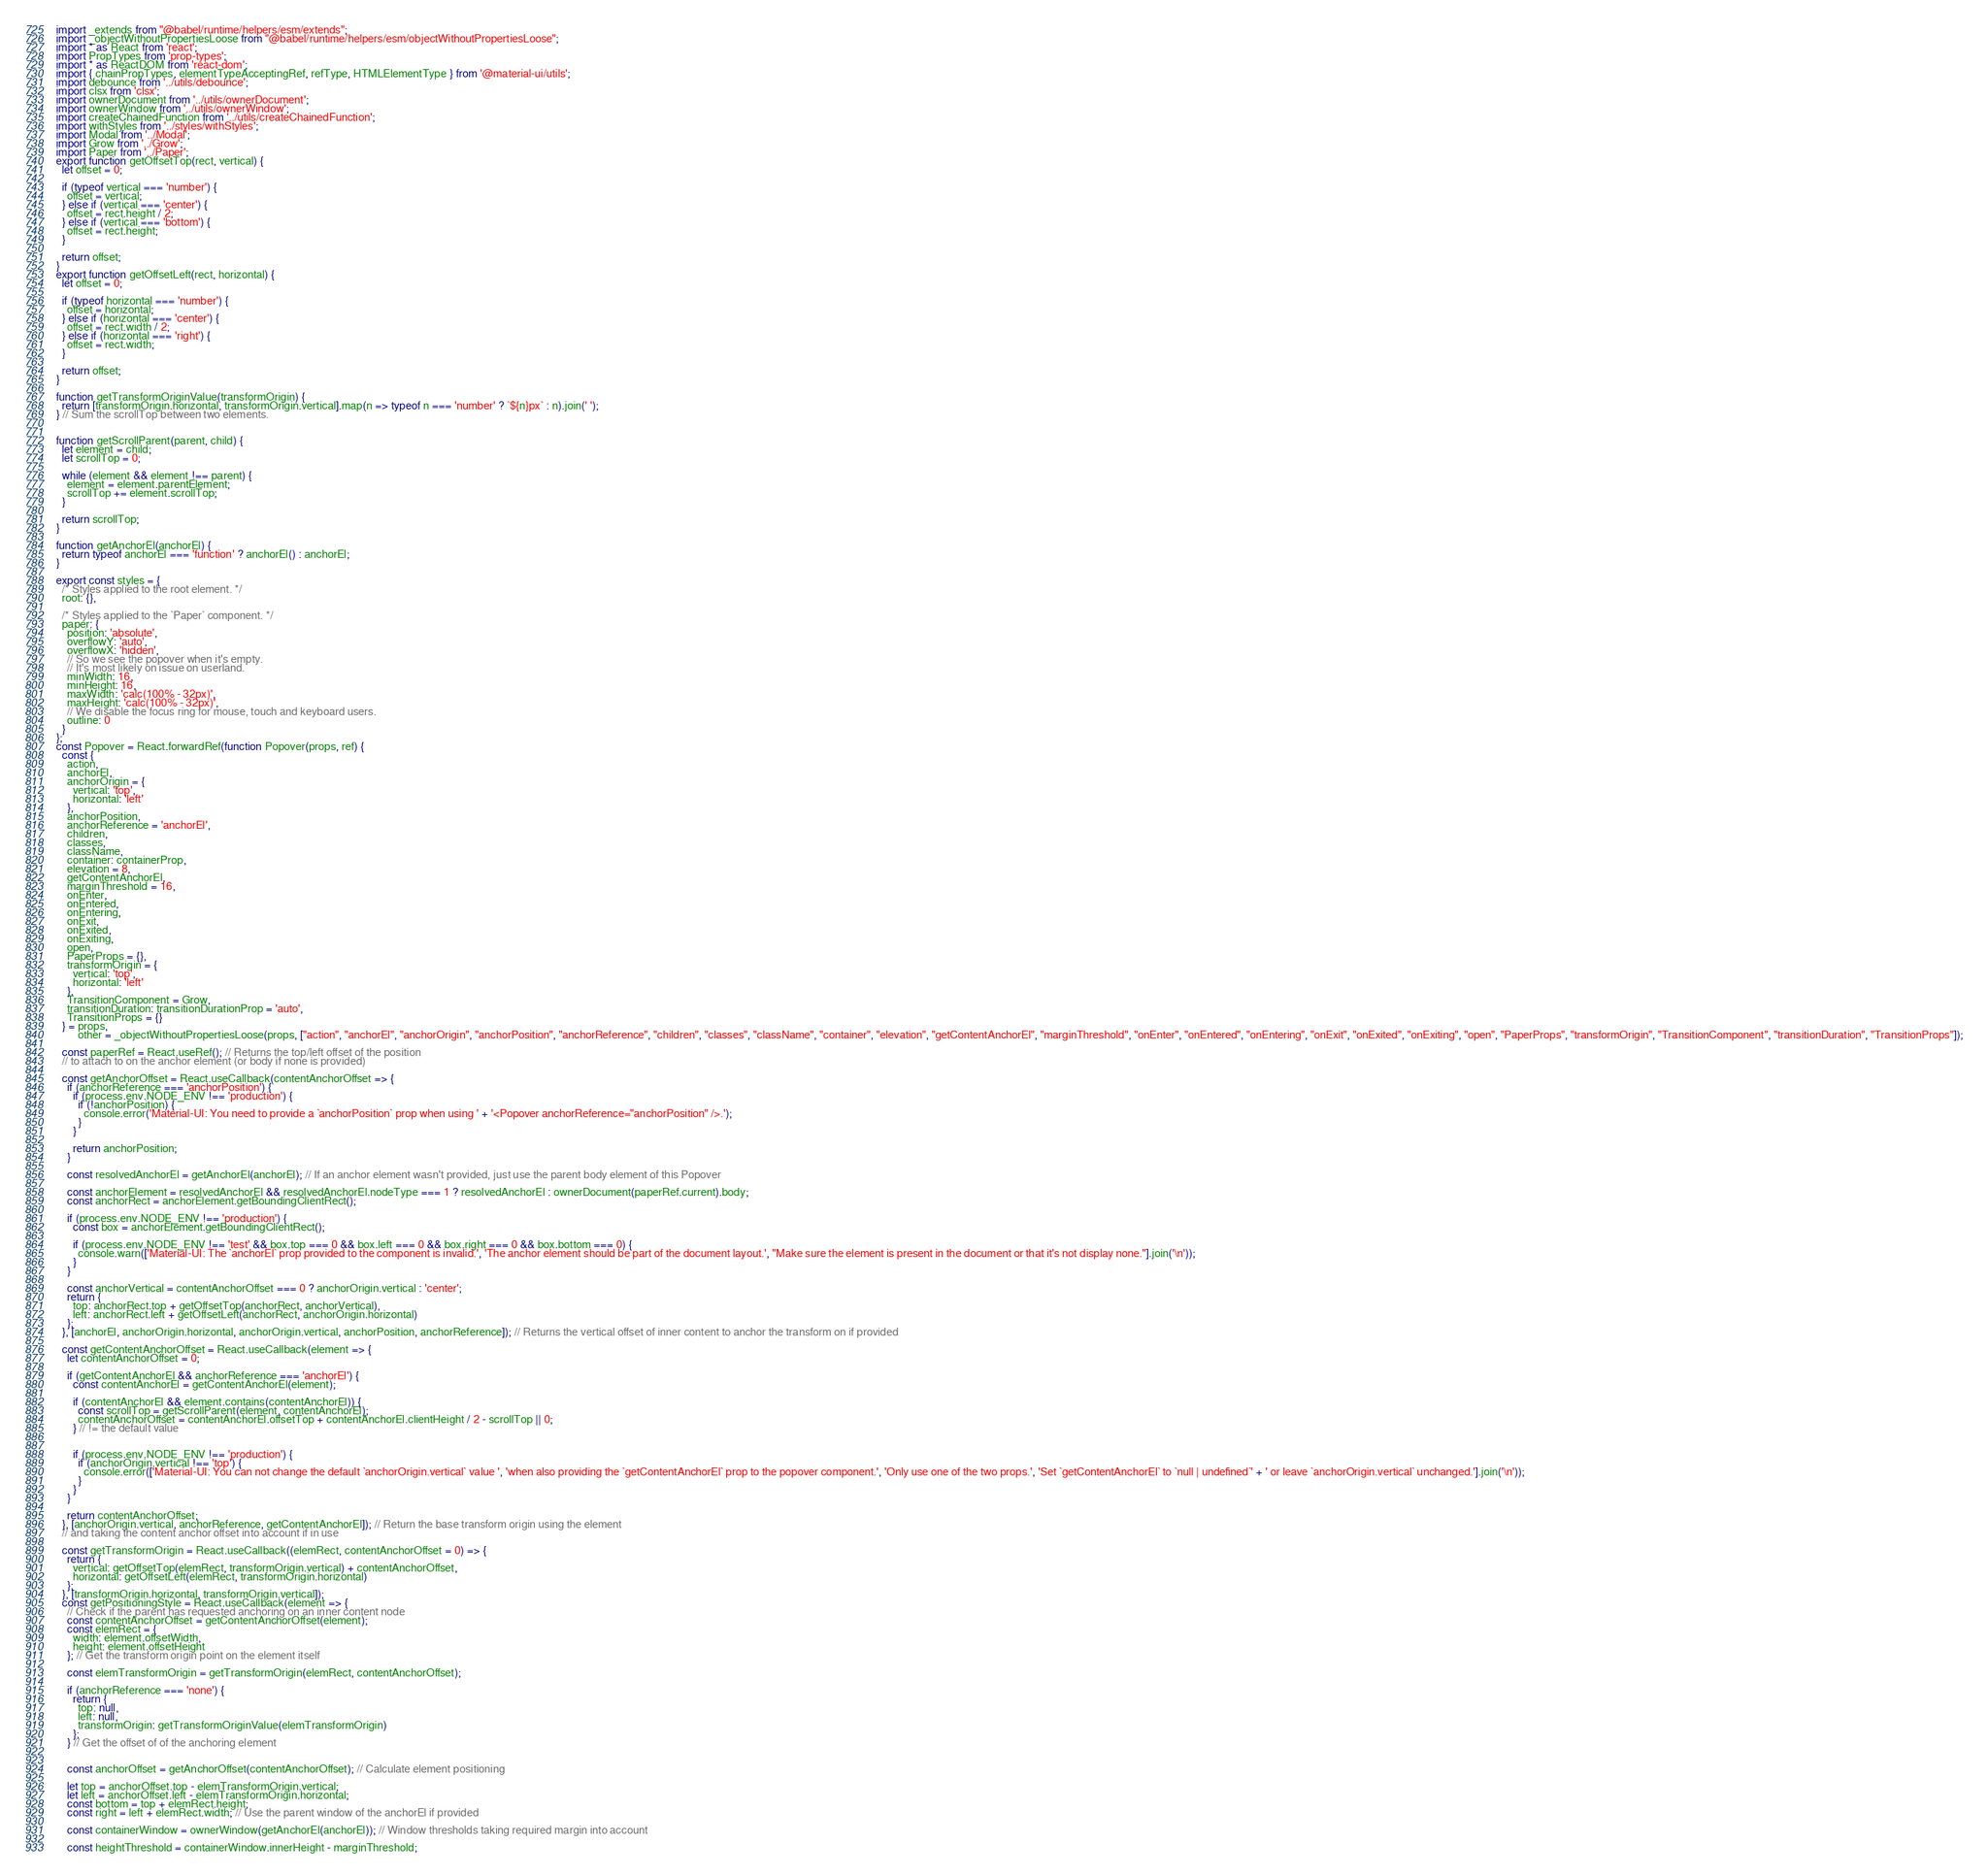<code> <loc_0><loc_0><loc_500><loc_500><_JavaScript_>import _extends from "@babel/runtime/helpers/esm/extends";
import _objectWithoutPropertiesLoose from "@babel/runtime/helpers/esm/objectWithoutPropertiesLoose";
import * as React from 'react';
import PropTypes from 'prop-types';
import * as ReactDOM from 'react-dom';
import { chainPropTypes, elementTypeAcceptingRef, refType, HTMLElementType } from '@material-ui/utils';
import debounce from '../utils/debounce';
import clsx from 'clsx';
import ownerDocument from '../utils/ownerDocument';
import ownerWindow from '../utils/ownerWindow';
import createChainedFunction from '../utils/createChainedFunction';
import withStyles from '../styles/withStyles';
import Modal from '../Modal';
import Grow from '../Grow';
import Paper from '../Paper';
export function getOffsetTop(rect, vertical) {
  let offset = 0;

  if (typeof vertical === 'number') {
    offset = vertical;
  } else if (vertical === 'center') {
    offset = rect.height / 2;
  } else if (vertical === 'bottom') {
    offset = rect.height;
  }

  return offset;
}
export function getOffsetLeft(rect, horizontal) {
  let offset = 0;

  if (typeof horizontal === 'number') {
    offset = horizontal;
  } else if (horizontal === 'center') {
    offset = rect.width / 2;
  } else if (horizontal === 'right') {
    offset = rect.width;
  }

  return offset;
}

function getTransformOriginValue(transformOrigin) {
  return [transformOrigin.horizontal, transformOrigin.vertical].map(n => typeof n === 'number' ? `${n}px` : n).join(' ');
} // Sum the scrollTop between two elements.


function getScrollParent(parent, child) {
  let element = child;
  let scrollTop = 0;

  while (element && element !== parent) {
    element = element.parentElement;
    scrollTop += element.scrollTop;
  }

  return scrollTop;
}

function getAnchorEl(anchorEl) {
  return typeof anchorEl === 'function' ? anchorEl() : anchorEl;
}

export const styles = {
  /* Styles applied to the root element. */
  root: {},

  /* Styles applied to the `Paper` component. */
  paper: {
    position: 'absolute',
    overflowY: 'auto',
    overflowX: 'hidden',
    // So we see the popover when it's empty.
    // It's most likely on issue on userland.
    minWidth: 16,
    minHeight: 16,
    maxWidth: 'calc(100% - 32px)',
    maxHeight: 'calc(100% - 32px)',
    // We disable the focus ring for mouse, touch and keyboard users.
    outline: 0
  }
};
const Popover = React.forwardRef(function Popover(props, ref) {
  const {
    action,
    anchorEl,
    anchorOrigin = {
      vertical: 'top',
      horizontal: 'left'
    },
    anchorPosition,
    anchorReference = 'anchorEl',
    children,
    classes,
    className,
    container: containerProp,
    elevation = 8,
    getContentAnchorEl,
    marginThreshold = 16,
    onEnter,
    onEntered,
    onEntering,
    onExit,
    onExited,
    onExiting,
    open,
    PaperProps = {},
    transformOrigin = {
      vertical: 'top',
      horizontal: 'left'
    },
    TransitionComponent = Grow,
    transitionDuration: transitionDurationProp = 'auto',
    TransitionProps = {}
  } = props,
        other = _objectWithoutPropertiesLoose(props, ["action", "anchorEl", "anchorOrigin", "anchorPosition", "anchorReference", "children", "classes", "className", "container", "elevation", "getContentAnchorEl", "marginThreshold", "onEnter", "onEntered", "onEntering", "onExit", "onExited", "onExiting", "open", "PaperProps", "transformOrigin", "TransitionComponent", "transitionDuration", "TransitionProps"]);

  const paperRef = React.useRef(); // Returns the top/left offset of the position
  // to attach to on the anchor element (or body if none is provided)

  const getAnchorOffset = React.useCallback(contentAnchorOffset => {
    if (anchorReference === 'anchorPosition') {
      if (process.env.NODE_ENV !== 'production') {
        if (!anchorPosition) {
          console.error('Material-UI: You need to provide a `anchorPosition` prop when using ' + '<Popover anchorReference="anchorPosition" />.');
        }
      }

      return anchorPosition;
    }

    const resolvedAnchorEl = getAnchorEl(anchorEl); // If an anchor element wasn't provided, just use the parent body element of this Popover

    const anchorElement = resolvedAnchorEl && resolvedAnchorEl.nodeType === 1 ? resolvedAnchorEl : ownerDocument(paperRef.current).body;
    const anchorRect = anchorElement.getBoundingClientRect();

    if (process.env.NODE_ENV !== 'production') {
      const box = anchorElement.getBoundingClientRect();

      if (process.env.NODE_ENV !== 'test' && box.top === 0 && box.left === 0 && box.right === 0 && box.bottom === 0) {
        console.warn(['Material-UI: The `anchorEl` prop provided to the component is invalid.', 'The anchor element should be part of the document layout.', "Make sure the element is present in the document or that it's not display none."].join('\n'));
      }
    }

    const anchorVertical = contentAnchorOffset === 0 ? anchorOrigin.vertical : 'center';
    return {
      top: anchorRect.top + getOffsetTop(anchorRect, anchorVertical),
      left: anchorRect.left + getOffsetLeft(anchorRect, anchorOrigin.horizontal)
    };
  }, [anchorEl, anchorOrigin.horizontal, anchorOrigin.vertical, anchorPosition, anchorReference]); // Returns the vertical offset of inner content to anchor the transform on if provided

  const getContentAnchorOffset = React.useCallback(element => {
    let contentAnchorOffset = 0;

    if (getContentAnchorEl && anchorReference === 'anchorEl') {
      const contentAnchorEl = getContentAnchorEl(element);

      if (contentAnchorEl && element.contains(contentAnchorEl)) {
        const scrollTop = getScrollParent(element, contentAnchorEl);
        contentAnchorOffset = contentAnchorEl.offsetTop + contentAnchorEl.clientHeight / 2 - scrollTop || 0;
      } // != the default value


      if (process.env.NODE_ENV !== 'production') {
        if (anchorOrigin.vertical !== 'top') {
          console.error(['Material-UI: You can not change the default `anchorOrigin.vertical` value ', 'when also providing the `getContentAnchorEl` prop to the popover component.', 'Only use one of the two props.', 'Set `getContentAnchorEl` to `null | undefined`' + ' or leave `anchorOrigin.vertical` unchanged.'].join('\n'));
        }
      }
    }

    return contentAnchorOffset;
  }, [anchorOrigin.vertical, anchorReference, getContentAnchorEl]); // Return the base transform origin using the element
  // and taking the content anchor offset into account if in use

  const getTransformOrigin = React.useCallback((elemRect, contentAnchorOffset = 0) => {
    return {
      vertical: getOffsetTop(elemRect, transformOrigin.vertical) + contentAnchorOffset,
      horizontal: getOffsetLeft(elemRect, transformOrigin.horizontal)
    };
  }, [transformOrigin.horizontal, transformOrigin.vertical]);
  const getPositioningStyle = React.useCallback(element => {
    // Check if the parent has requested anchoring on an inner content node
    const contentAnchorOffset = getContentAnchorOffset(element);
    const elemRect = {
      width: element.offsetWidth,
      height: element.offsetHeight
    }; // Get the transform origin point on the element itself

    const elemTransformOrigin = getTransformOrigin(elemRect, contentAnchorOffset);

    if (anchorReference === 'none') {
      return {
        top: null,
        left: null,
        transformOrigin: getTransformOriginValue(elemTransformOrigin)
      };
    } // Get the offset of of the anchoring element


    const anchorOffset = getAnchorOffset(contentAnchorOffset); // Calculate element positioning

    let top = anchorOffset.top - elemTransformOrigin.vertical;
    let left = anchorOffset.left - elemTransformOrigin.horizontal;
    const bottom = top + elemRect.height;
    const right = left + elemRect.width; // Use the parent window of the anchorEl if provided

    const containerWindow = ownerWindow(getAnchorEl(anchorEl)); // Window thresholds taking required margin into account

    const heightThreshold = containerWindow.innerHeight - marginThreshold;</code> 